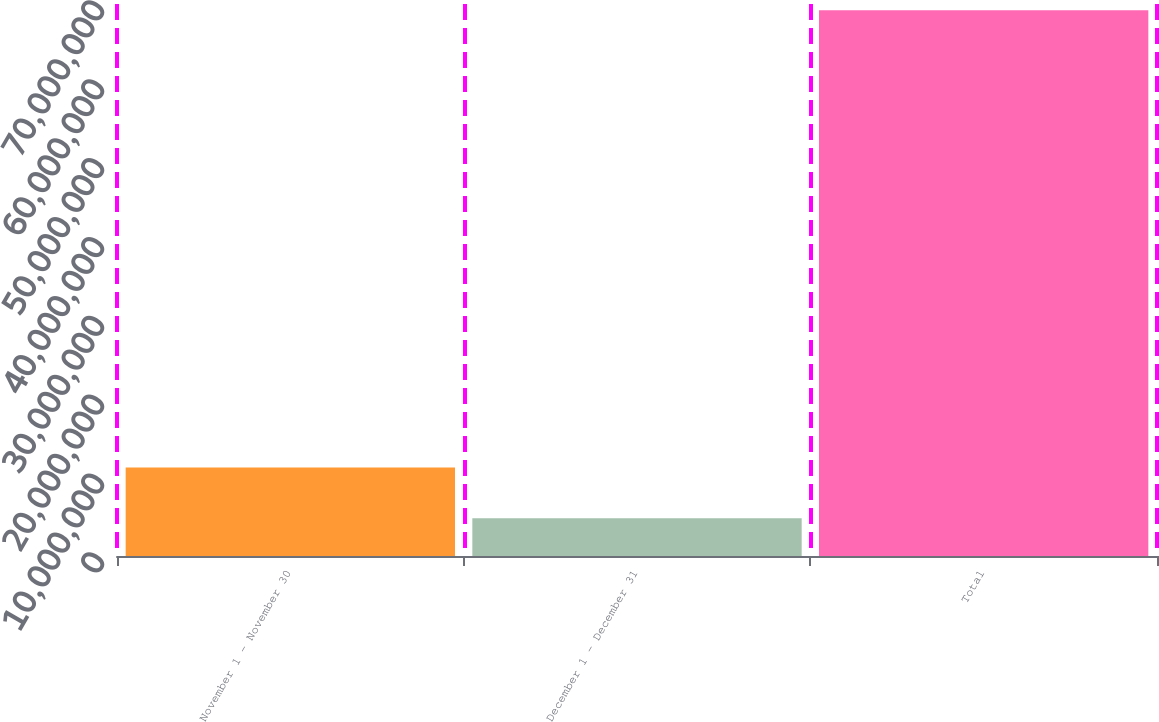Convert chart to OTSL. <chart><loc_0><loc_0><loc_500><loc_500><bar_chart><fcel>November 1 - November 30<fcel>December 1 - December 31<fcel>Total<nl><fcel>1.12319e+07<fcel>4.78853e+06<fcel>6.92223e+07<nl></chart> 